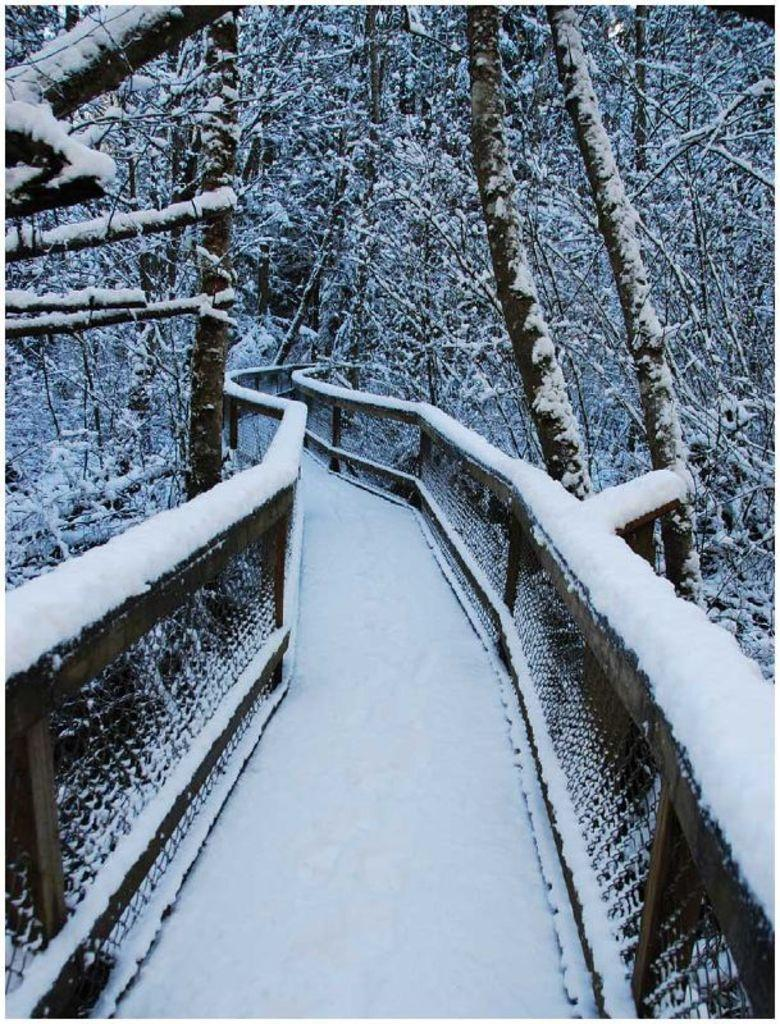What type of structure is present in the image? There is a bridge with a railing in the image. What natural elements can be seen in the image? There are trees in the image. What weather condition is depicted in the image? Snowfall is visible on the bridge and trees in the image. What record-breaking temperature is being experienced by the team in the image? There is no team or record-breaking temperature mentioned in the image; it only shows a bridge, trees, and snowfall. 